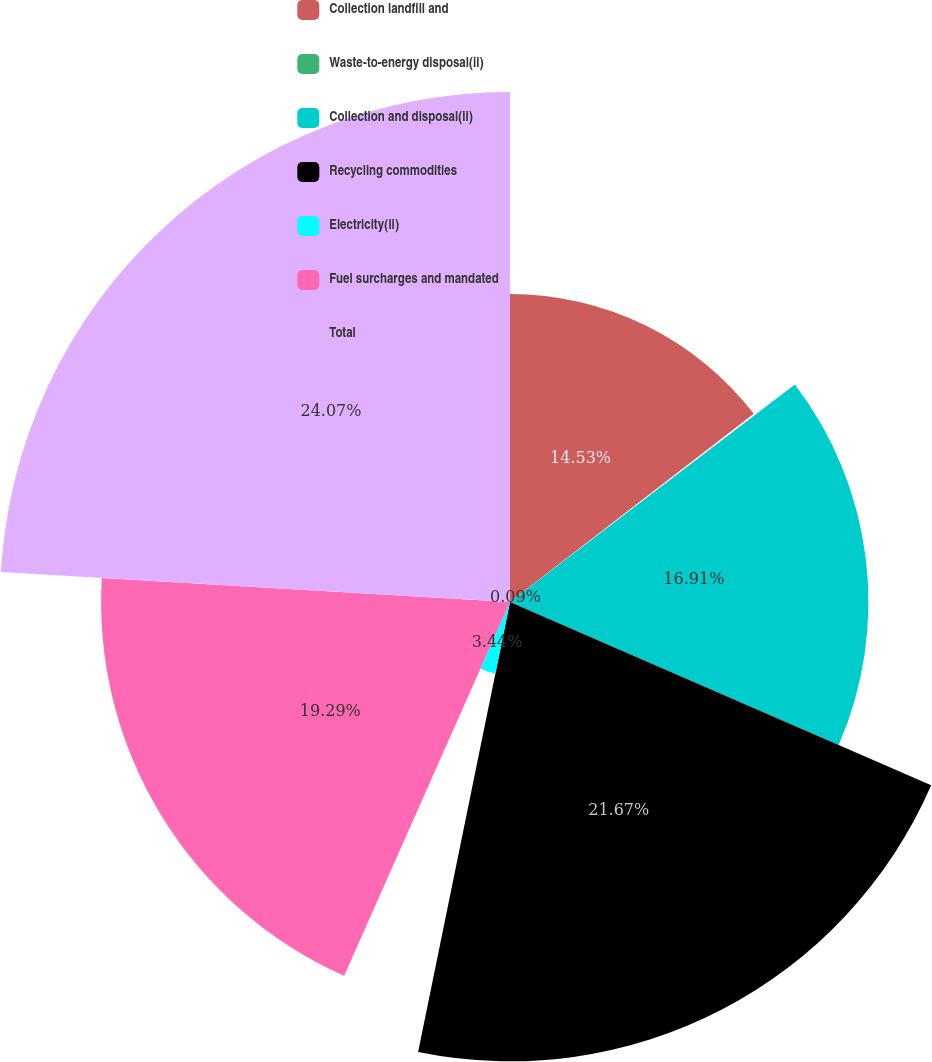<chart> <loc_0><loc_0><loc_500><loc_500><pie_chart><fcel>Collection landfill and<fcel>Waste-to-energy disposal(ii)<fcel>Collection and disposal(ii)<fcel>Recycling commodities<fcel>Electricity(ii)<fcel>Fuel surcharges and mandated<fcel>Total<nl><fcel>14.53%<fcel>0.09%<fcel>16.91%<fcel>21.67%<fcel>3.44%<fcel>19.29%<fcel>24.06%<nl></chart> 